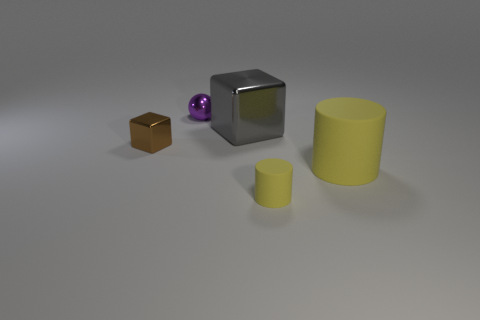Add 5 metallic cylinders. How many objects exist? 10 Subtract all cubes. How many objects are left? 3 Add 5 matte things. How many matte things are left? 7 Add 4 purple spheres. How many purple spheres exist? 5 Subtract 0 gray balls. How many objects are left? 5 Subtract all small yellow cylinders. Subtract all rubber cylinders. How many objects are left? 2 